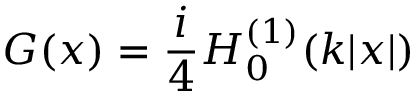Convert formula to latex. <formula><loc_0><loc_0><loc_500><loc_500>G ( x ) = { \frac { i } { 4 } } H _ { 0 } ^ { ( 1 ) } ( k | x | )</formula> 